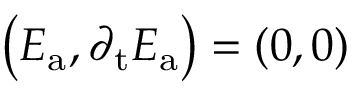Convert formula to latex. <formula><loc_0><loc_0><loc_500><loc_500>\left ( E _ { a } , \partial _ { t } E _ { a } \right ) = \left ( 0 , 0 \right )</formula> 